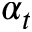<formula> <loc_0><loc_0><loc_500><loc_500>\alpha _ { t }</formula> 